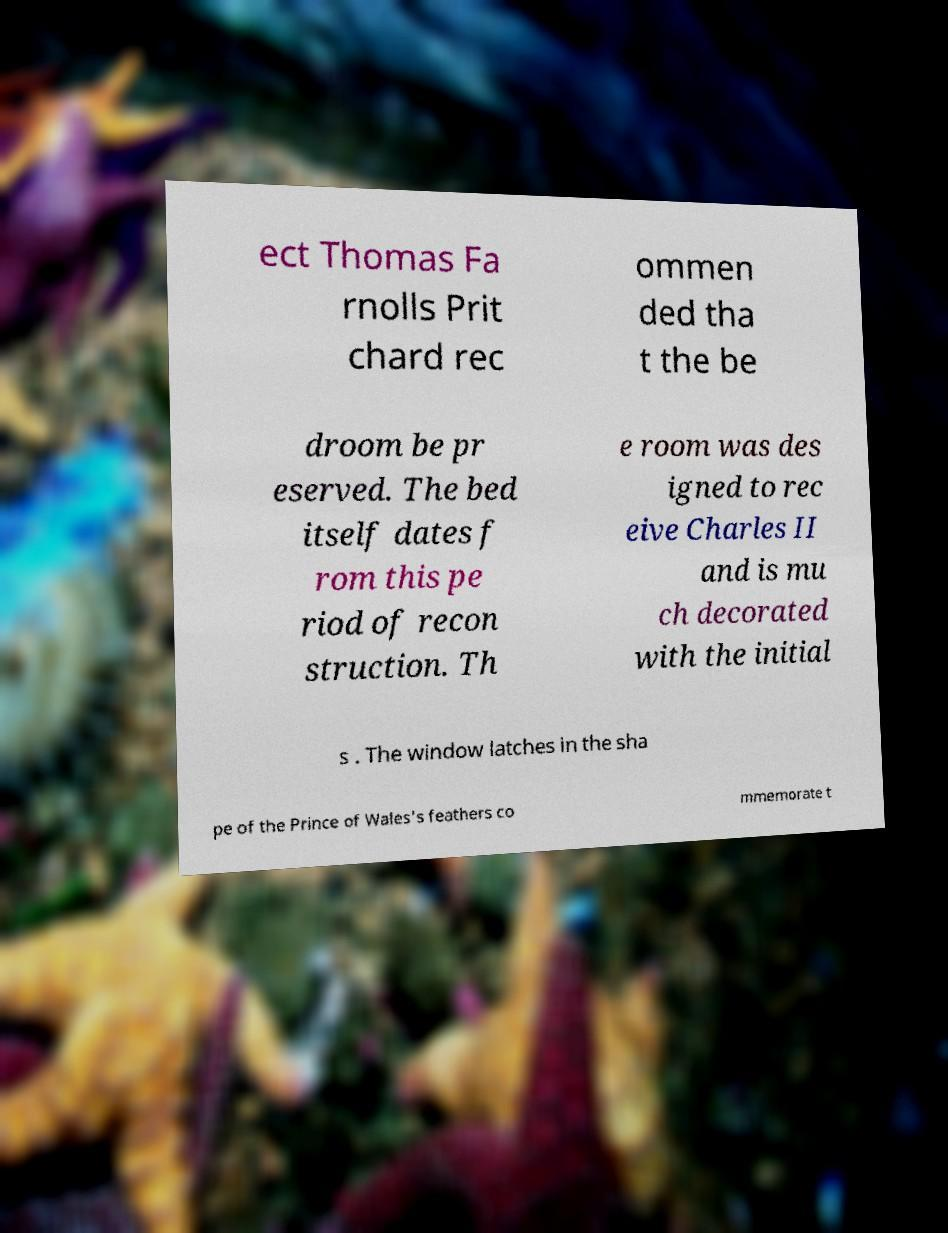Please identify and transcribe the text found in this image. ect Thomas Fa rnolls Prit chard rec ommen ded tha t the be droom be pr eserved. The bed itself dates f rom this pe riod of recon struction. Th e room was des igned to rec eive Charles II and is mu ch decorated with the initial s . The window latches in the sha pe of the Prince of Wales's feathers co mmemorate t 